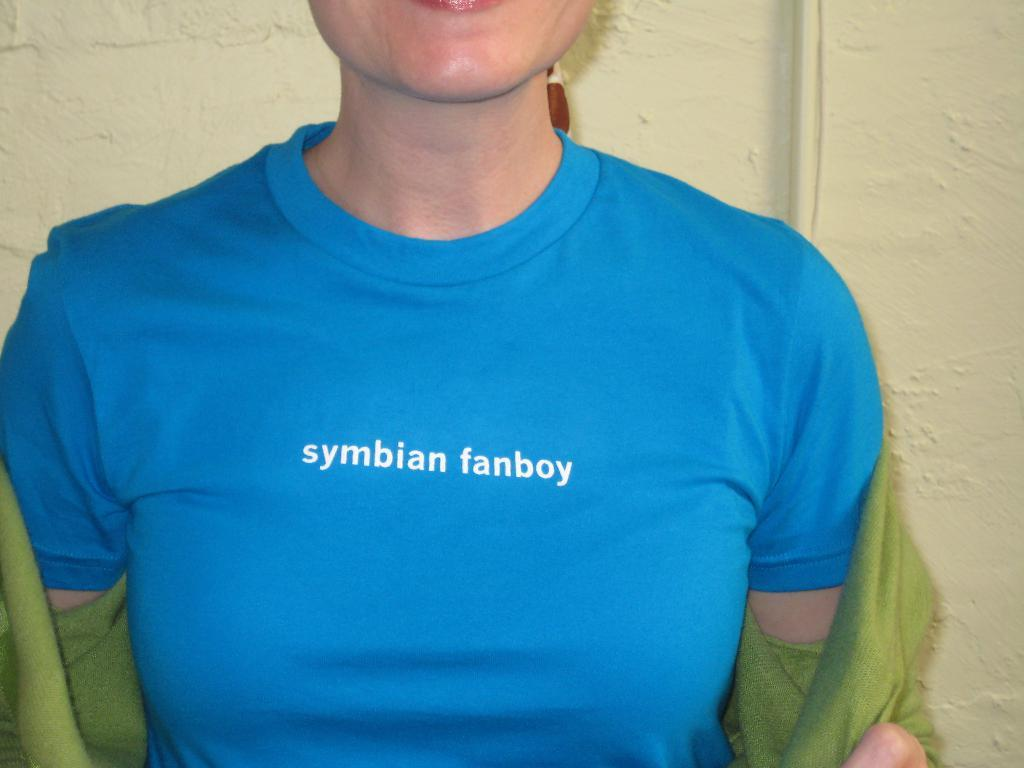Who or what is present in the image? There is a person in the image. What can be observed about the person's attire? The person is wearing clothes. What can be seen in the background of the image? There is a wall in the background of the image. What type of polish is the person applying to their hair in the image? There is no indication in the image that the person is applying any polish to their hair. 